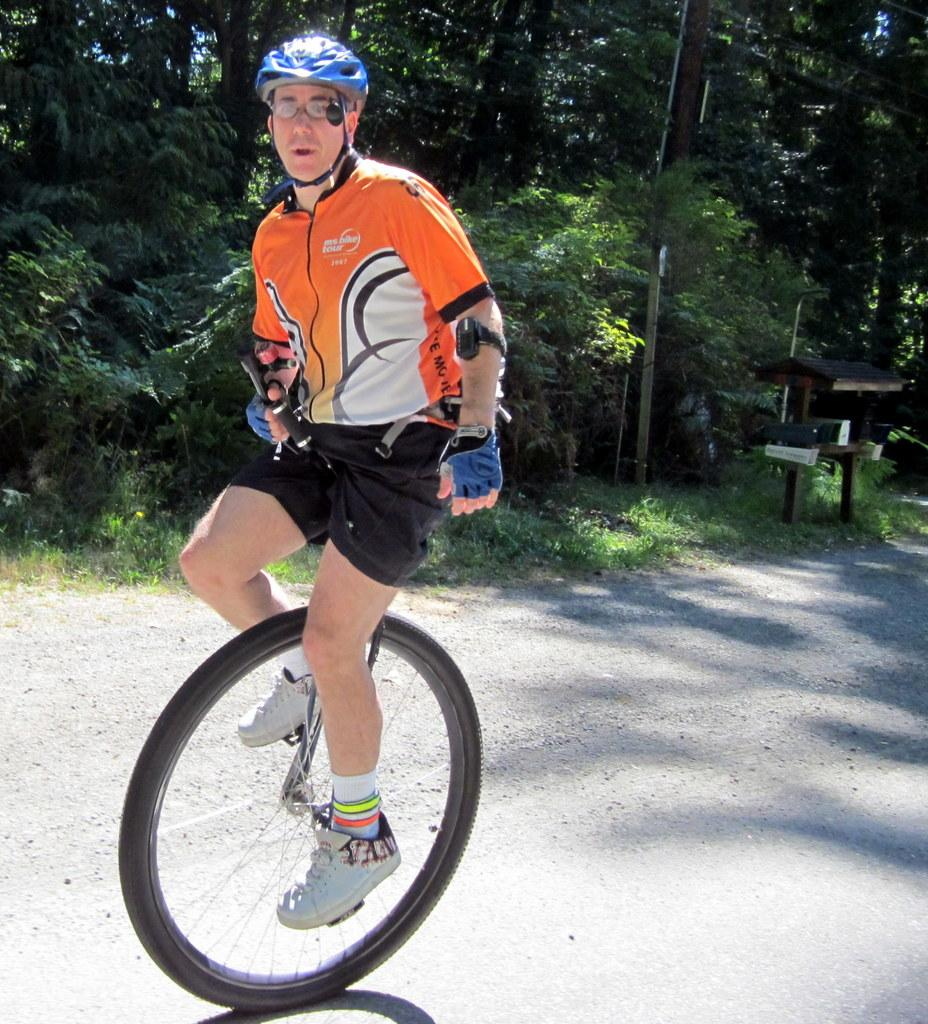What is the main subject of the image? There is a man in the image. What is the man wearing on his upper body? The man is wearing a jacket. What is the man wearing on his lower body? The man is wearing shorts. What is the man wearing on his head? The man is wearing a helmet on his head. What activity is the man engaged in? The man is cycling on the road. What can be seen in the background of the image? There are many trees and a pole in the background of the image. What type of cup can be seen in the man's hand in the image? There is no cup visible in the man's hand in the image. What is the root of the trees in the background of the image? The image does not show the roots of the trees; it only shows the trees themselves. 